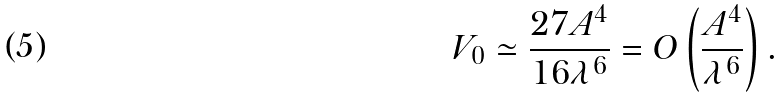<formula> <loc_0><loc_0><loc_500><loc_500>V _ { 0 } \simeq \frac { 2 7 A ^ { 4 } } { 1 6 \lambda ^ { 6 } } = O \left ( \frac { A ^ { 4 } } { \lambda ^ { 6 } } \right ) .</formula> 